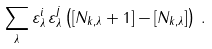Convert formula to latex. <formula><loc_0><loc_0><loc_500><loc_500>\sum _ { \lambda } \varepsilon ^ { i } _ { \lambda } \, \varepsilon ^ { j } _ { \lambda } \left ( [ N _ { { k } , \lambda } + 1 ] - [ N _ { { k } , \lambda } ] \right ) \, .</formula> 